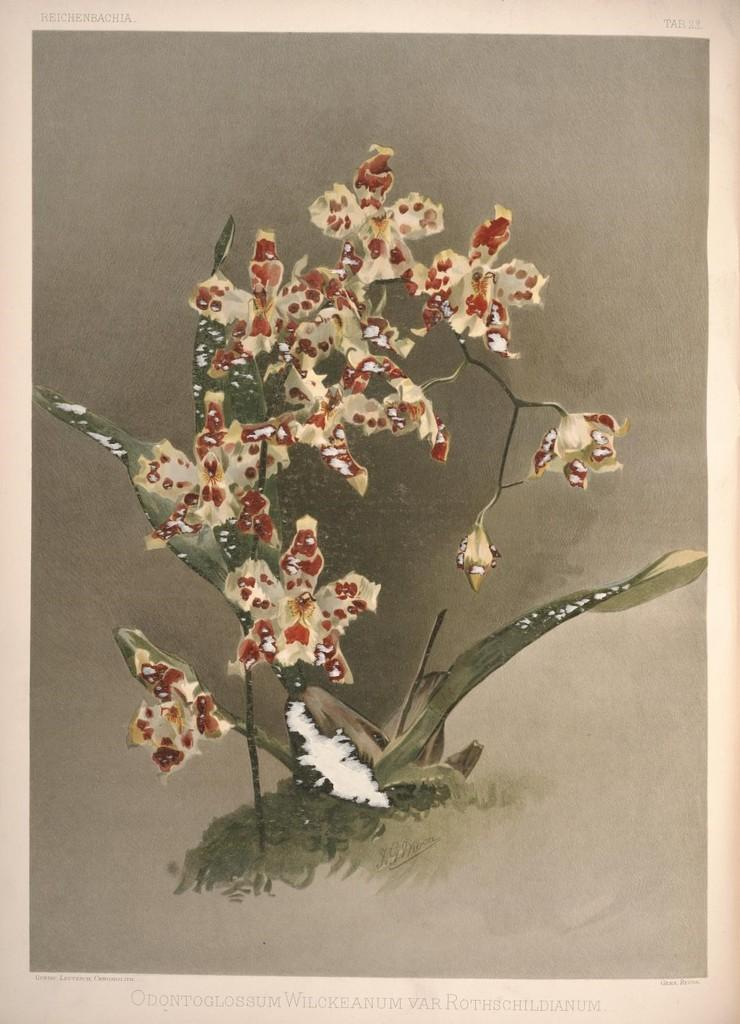What is featured in the image? There is a poster in the image. What is depicted on the poster? The poster has an image of a plant. Is there any text on the poster? Yes, there is text at the bottom of the image. What type of metal is used to make the plant in the image? The image is a poster, not a physical plant, so there is no metal used in the image. 